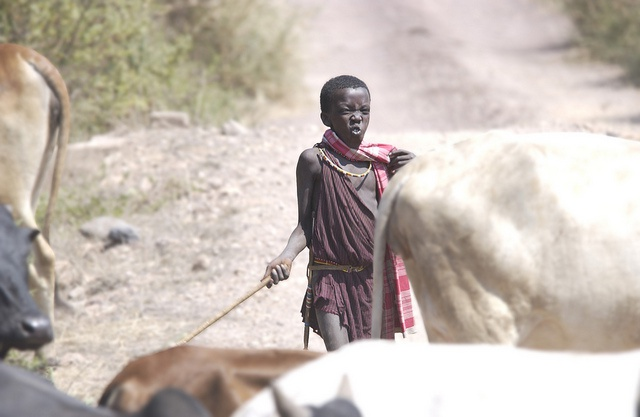Describe the objects in this image and their specific colors. I can see cow in gray, white, and darkgray tones, cow in gray, white, and darkgray tones, people in gray, black, and darkgray tones, cow in gray, darkgray, tan, and lightgray tones, and cow in gray and tan tones in this image. 